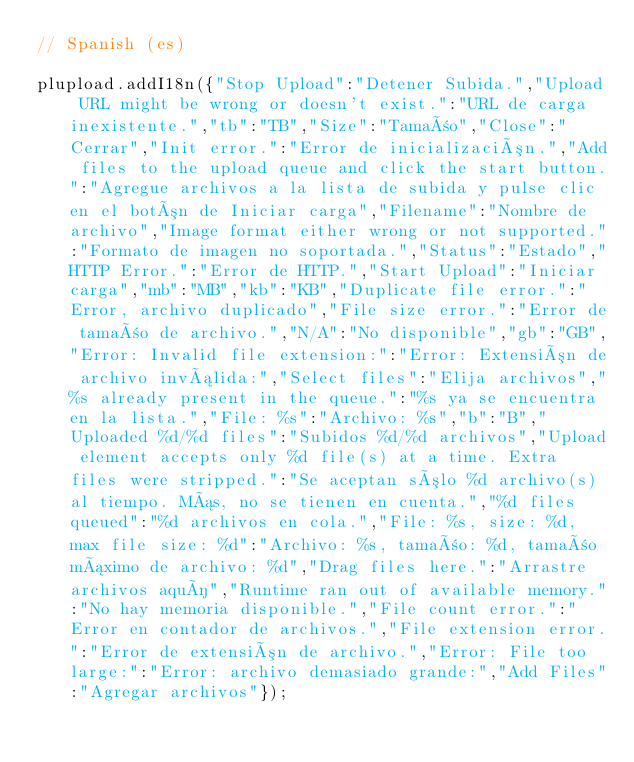Convert code to text. <code><loc_0><loc_0><loc_500><loc_500><_JavaScript_>// Spanish (es)
plupload.addI18n({"Stop Upload":"Detener Subida.","Upload URL might be wrong or doesn't exist.":"URL de carga inexistente.","tb":"TB","Size":"Tamaño","Close":"Cerrar","Init error.":"Error de inicialización.","Add files to the upload queue and click the start button.":"Agregue archivos a la lista de subida y pulse clic en el botón de Iniciar carga","Filename":"Nombre de archivo","Image format either wrong or not supported.":"Formato de imagen no soportada.","Status":"Estado","HTTP Error.":"Error de HTTP.","Start Upload":"Iniciar carga","mb":"MB","kb":"KB","Duplicate file error.":"Error, archivo duplicado","File size error.":"Error de tamaño de archivo.","N/A":"No disponible","gb":"GB","Error: Invalid file extension:":"Error: Extensión de archivo inválida:","Select files":"Elija archivos","%s already present in the queue.":"%s ya se encuentra en la lista.","File: %s":"Archivo: %s","b":"B","Uploaded %d/%d files":"Subidos %d/%d archivos","Upload element accepts only %d file(s) at a time. Extra files were stripped.":"Se aceptan sólo %d archivo(s) al tiempo. Más, no se tienen en cuenta.","%d files queued":"%d archivos en cola.","File: %s, size: %d, max file size: %d":"Archivo: %s, tamaño: %d, tamaño máximo de archivo: %d","Drag files here.":"Arrastre archivos aquí","Runtime ran out of available memory.":"No hay memoria disponible.","File count error.":"Error en contador de archivos.","File extension error.":"Error de extensión de archivo.","Error: File too large:":"Error: archivo demasiado grande:","Add Files":"Agregar archivos"});</code> 